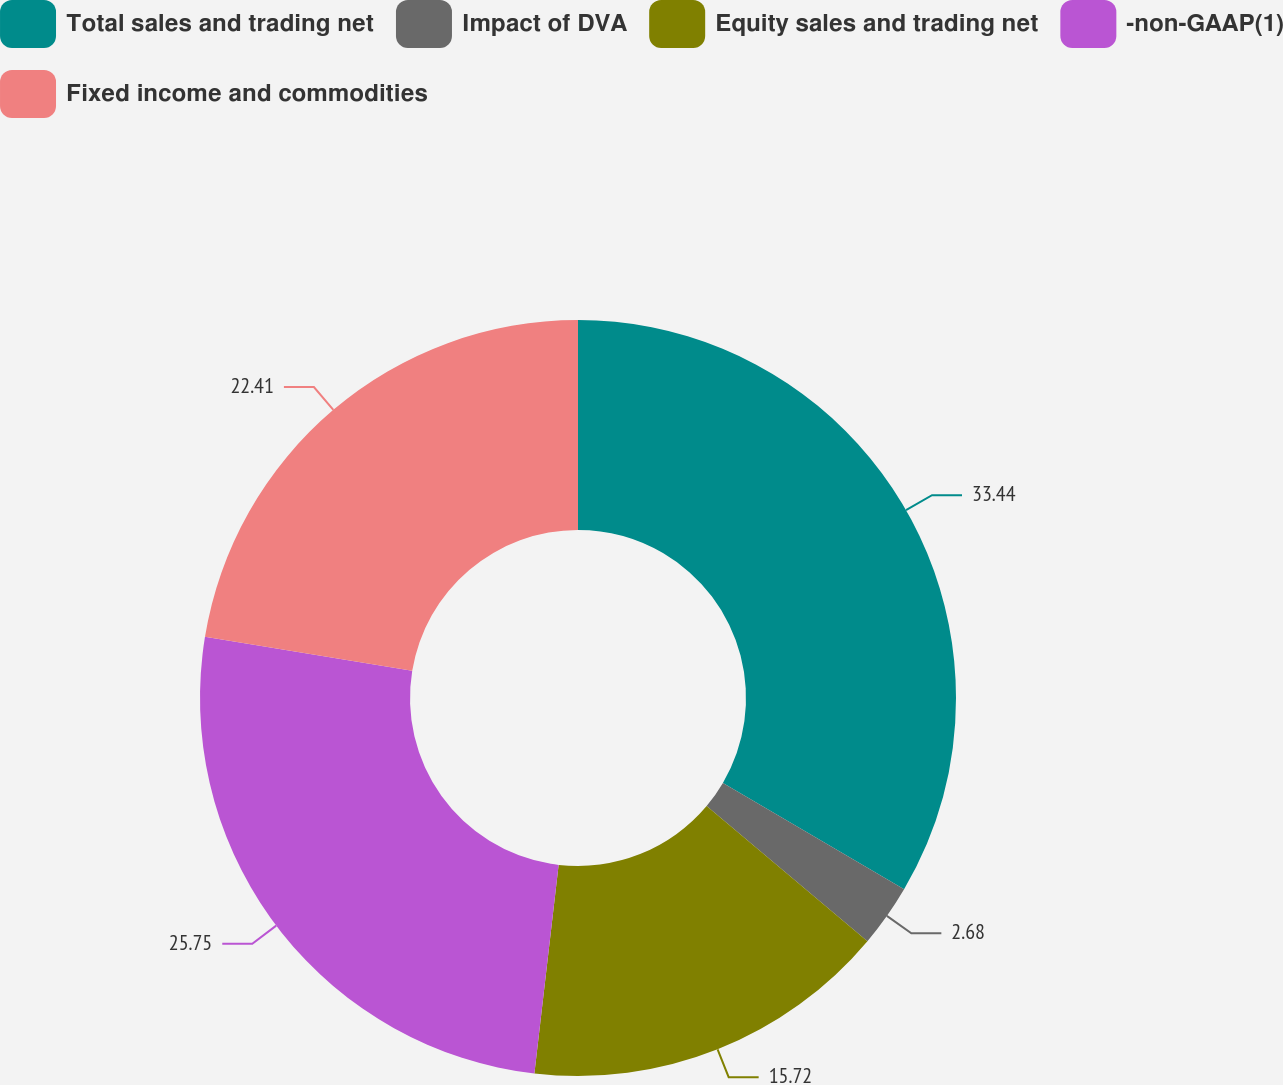Convert chart. <chart><loc_0><loc_0><loc_500><loc_500><pie_chart><fcel>Total sales and trading net<fcel>Impact of DVA<fcel>Equity sales and trading net<fcel>-non-GAAP(1)<fcel>Fixed income and commodities<nl><fcel>33.44%<fcel>2.68%<fcel>15.72%<fcel>25.75%<fcel>22.41%<nl></chart> 